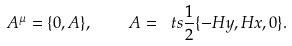<formula> <loc_0><loc_0><loc_500><loc_500>A ^ { \mu } = \{ 0 , { A } \} , \quad { A } = { \ t s \frac { 1 } { 2 } } \{ - H y , H x , 0 \} .</formula> 